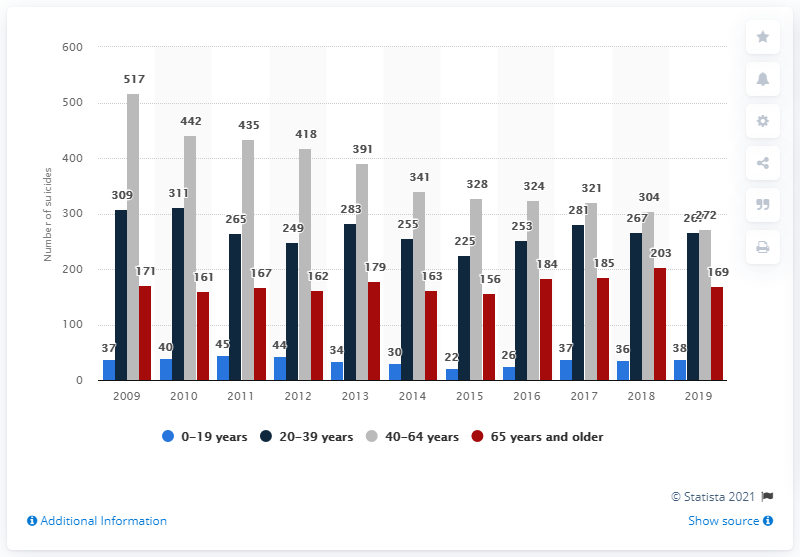Indicate a few pertinent items in this graphic. In 2019, there were 272 reported cases of suicide in Finland. In 2009, a total of 517 individuals committed suicide. 